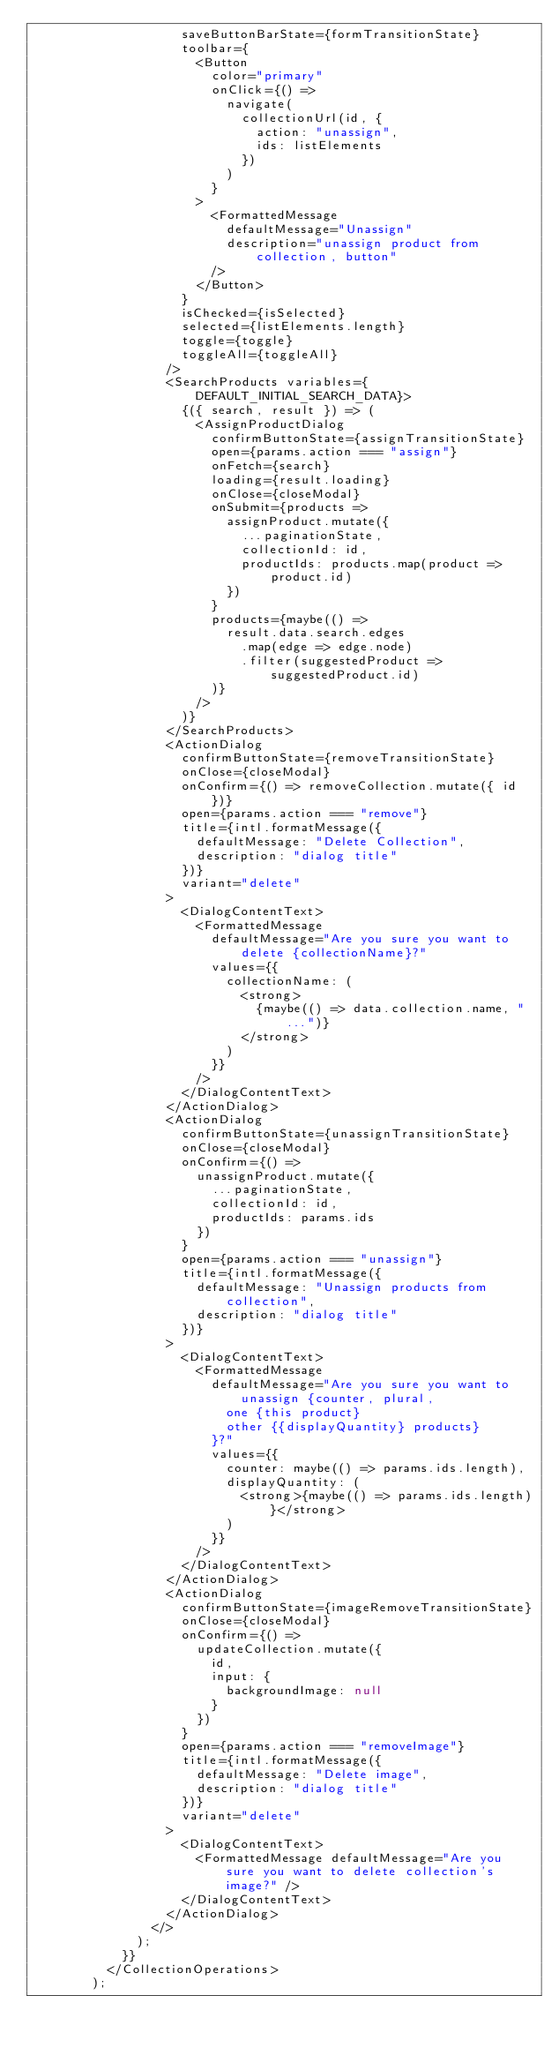<code> <loc_0><loc_0><loc_500><loc_500><_TypeScript_>                    saveButtonBarState={formTransitionState}
                    toolbar={
                      <Button
                        color="primary"
                        onClick={() =>
                          navigate(
                            collectionUrl(id, {
                              action: "unassign",
                              ids: listElements
                            })
                          )
                        }
                      >
                        <FormattedMessage
                          defaultMessage="Unassign"
                          description="unassign product from collection, button"
                        />
                      </Button>
                    }
                    isChecked={isSelected}
                    selected={listElements.length}
                    toggle={toggle}
                    toggleAll={toggleAll}
                  />
                  <SearchProducts variables={DEFAULT_INITIAL_SEARCH_DATA}>
                    {({ search, result }) => (
                      <AssignProductDialog
                        confirmButtonState={assignTransitionState}
                        open={params.action === "assign"}
                        onFetch={search}
                        loading={result.loading}
                        onClose={closeModal}
                        onSubmit={products =>
                          assignProduct.mutate({
                            ...paginationState,
                            collectionId: id,
                            productIds: products.map(product => product.id)
                          })
                        }
                        products={maybe(() =>
                          result.data.search.edges
                            .map(edge => edge.node)
                            .filter(suggestedProduct => suggestedProduct.id)
                        )}
                      />
                    )}
                  </SearchProducts>
                  <ActionDialog
                    confirmButtonState={removeTransitionState}
                    onClose={closeModal}
                    onConfirm={() => removeCollection.mutate({ id })}
                    open={params.action === "remove"}
                    title={intl.formatMessage({
                      defaultMessage: "Delete Collection",
                      description: "dialog title"
                    })}
                    variant="delete"
                  >
                    <DialogContentText>
                      <FormattedMessage
                        defaultMessage="Are you sure you want to delete {collectionName}?"
                        values={{
                          collectionName: (
                            <strong>
                              {maybe(() => data.collection.name, "...")}
                            </strong>
                          )
                        }}
                      />
                    </DialogContentText>
                  </ActionDialog>
                  <ActionDialog
                    confirmButtonState={unassignTransitionState}
                    onClose={closeModal}
                    onConfirm={() =>
                      unassignProduct.mutate({
                        ...paginationState,
                        collectionId: id,
                        productIds: params.ids
                      })
                    }
                    open={params.action === "unassign"}
                    title={intl.formatMessage({
                      defaultMessage: "Unassign products from collection",
                      description: "dialog title"
                    })}
                  >
                    <DialogContentText>
                      <FormattedMessage
                        defaultMessage="Are you sure you want to unassign {counter, plural,
                          one {this product}
                          other {{displayQuantity} products}
                        }?"
                        values={{
                          counter: maybe(() => params.ids.length),
                          displayQuantity: (
                            <strong>{maybe(() => params.ids.length)}</strong>
                          )
                        }}
                      />
                    </DialogContentText>
                  </ActionDialog>
                  <ActionDialog
                    confirmButtonState={imageRemoveTransitionState}
                    onClose={closeModal}
                    onConfirm={() =>
                      updateCollection.mutate({
                        id,
                        input: {
                          backgroundImage: null
                        }
                      })
                    }
                    open={params.action === "removeImage"}
                    title={intl.formatMessage({
                      defaultMessage: "Delete image",
                      description: "dialog title"
                    })}
                    variant="delete"
                  >
                    <DialogContentText>
                      <FormattedMessage defaultMessage="Are you sure you want to delete collection's image?" />
                    </DialogContentText>
                  </ActionDialog>
                </>
              );
            }}
          </CollectionOperations>
        );</code> 